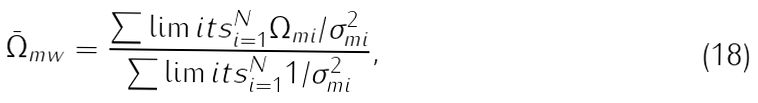Convert formula to latex. <formula><loc_0><loc_0><loc_500><loc_500>\bar { \Omega } _ { m w } = \frac { \sum \lim i t s _ { i = 1 } ^ { N } \Omega _ { m i } / \sigma _ { m i } ^ { 2 } } { \sum \lim i t s _ { i = 1 } ^ { N } 1 / \sigma _ { m i } ^ { 2 } } ,</formula> 